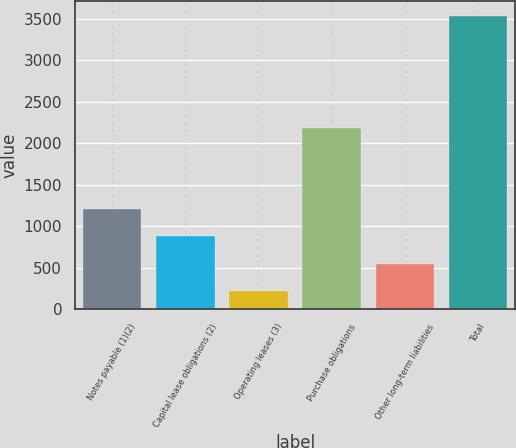Convert chart to OTSL. <chart><loc_0><loc_0><loc_500><loc_500><bar_chart><fcel>Notes payable (1)(2)<fcel>Capital lease obligations (2)<fcel>Operating leases (3)<fcel>Purchase obligations<fcel>Other long-term liabilities<fcel>Total<nl><fcel>1212.8<fcel>881.2<fcel>218<fcel>2189<fcel>549.6<fcel>3534<nl></chart> 